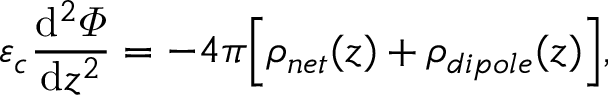Convert formula to latex. <formula><loc_0><loc_0><loc_500><loc_500>\varepsilon _ { c } \frac { d ^ { 2 } \varPhi } { d z ^ { 2 } } = - 4 \pi \left [ \rho _ { n e t } ( z ) + \rho _ { d i p o l e } ( z ) \right ] ,</formula> 